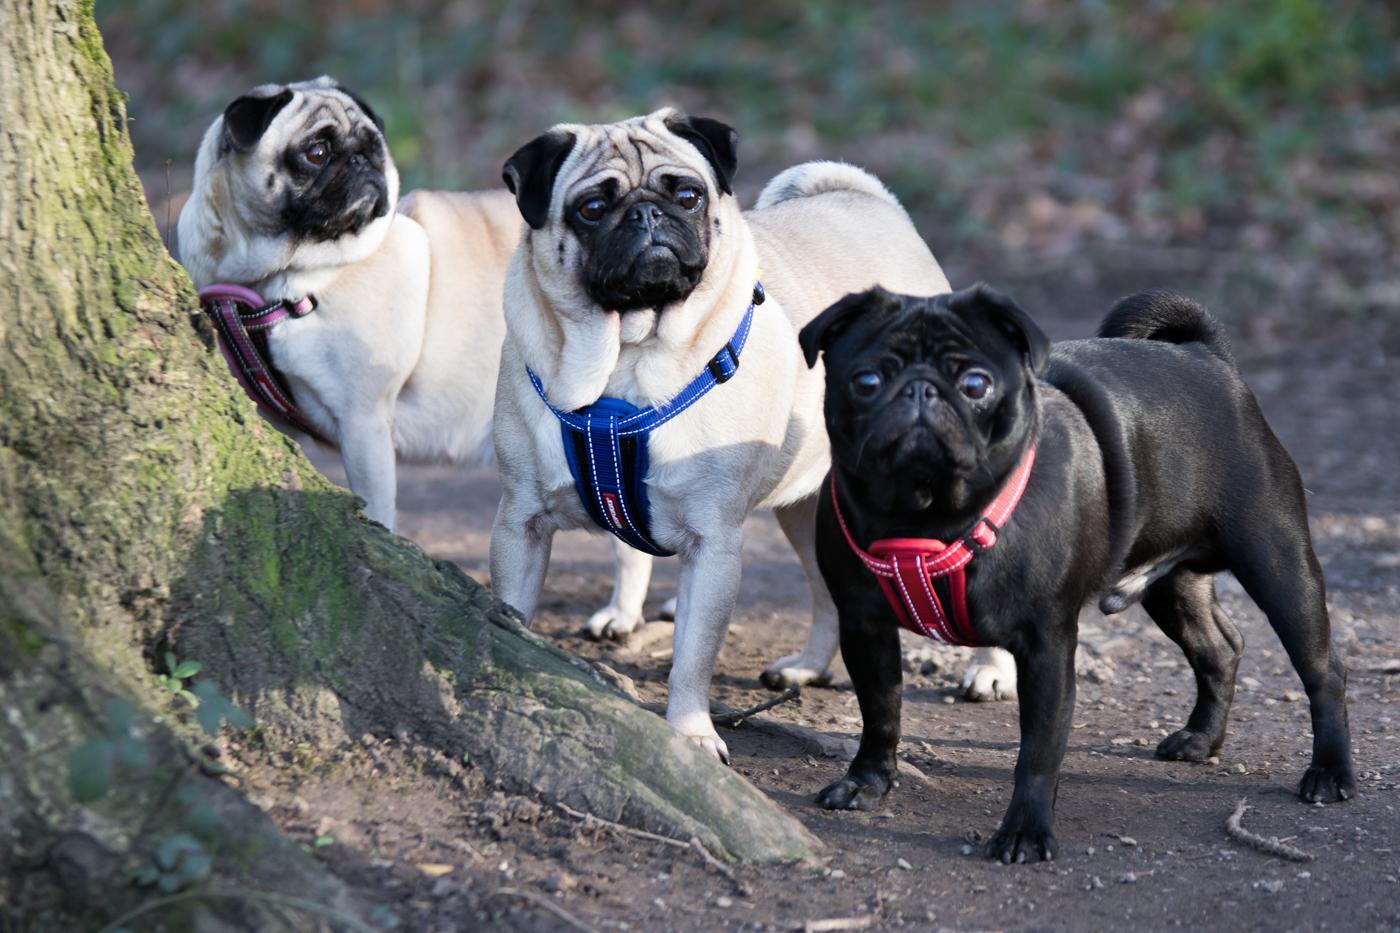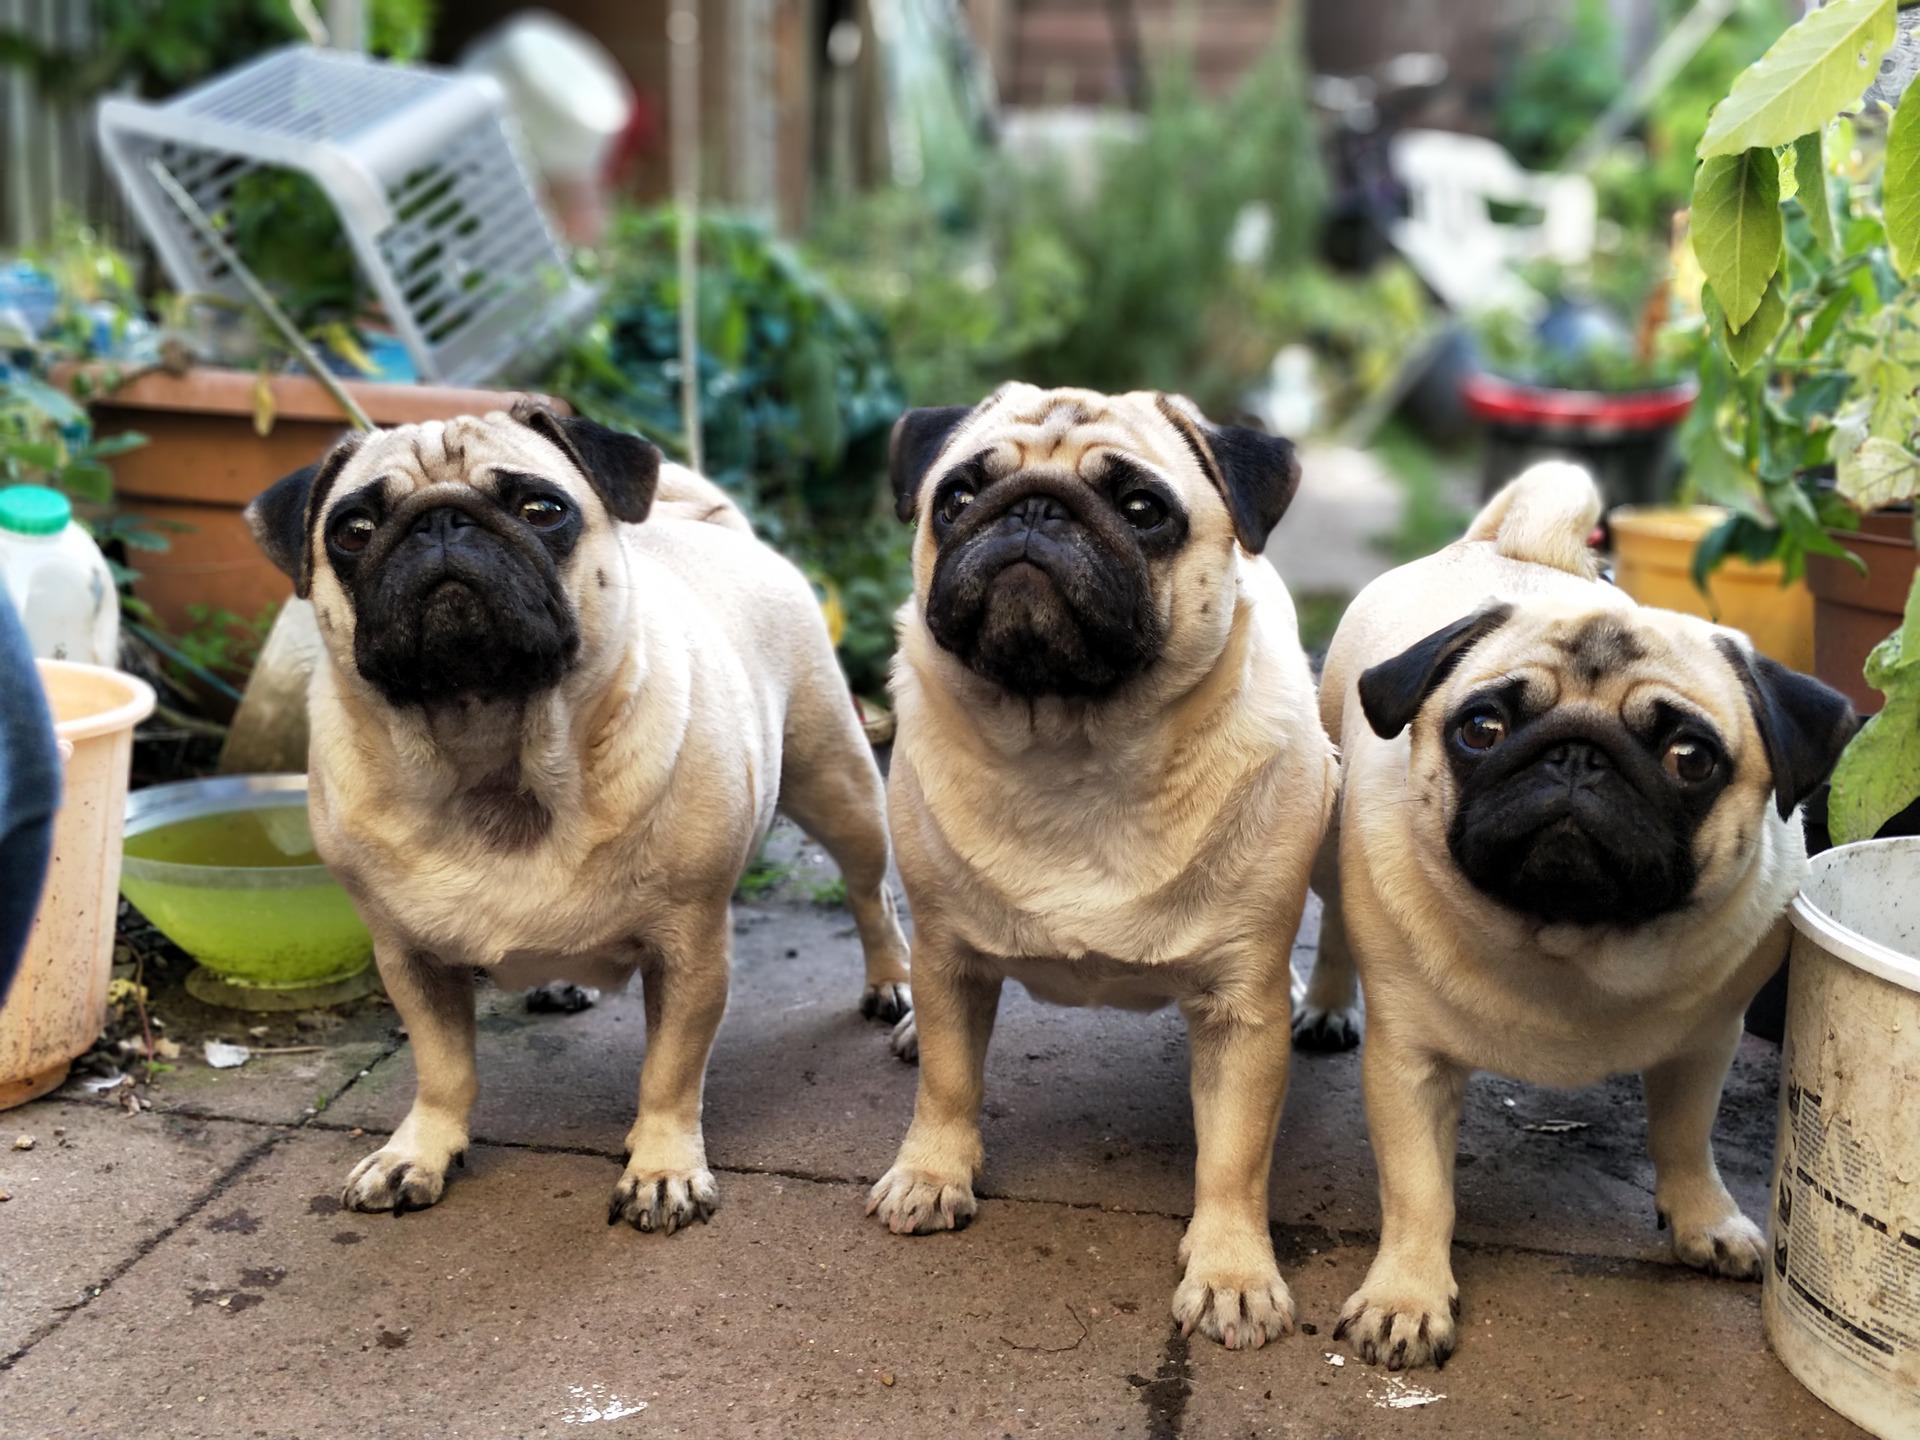The first image is the image on the left, the second image is the image on the right. Given the left and right images, does the statement "Three dogs are in a row, shoulder to shoulder in one of the images." hold true? Answer yes or no. Yes. The first image is the image on the left, the second image is the image on the right. Examine the images to the left and right. Is the description "One image shows three pugs posed like a conga line, two of them facing another's back with front paws around its midsection." accurate? Answer yes or no. No. 